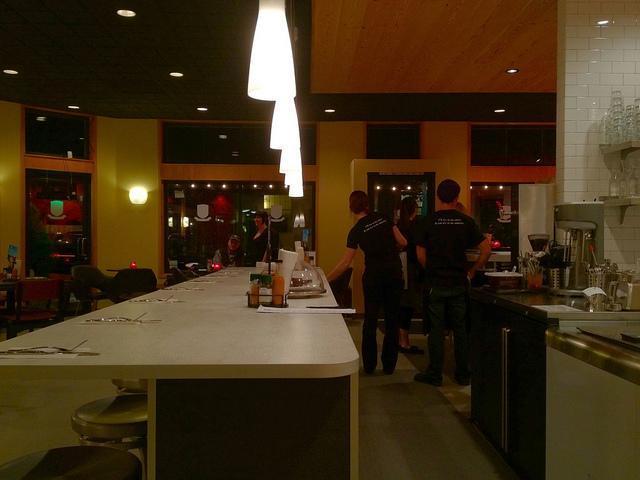How many televisions are there in the mall?
Give a very brief answer. 0. How many chairs are there?
Give a very brief answer. 4. How many people are there?
Give a very brief answer. 2. 